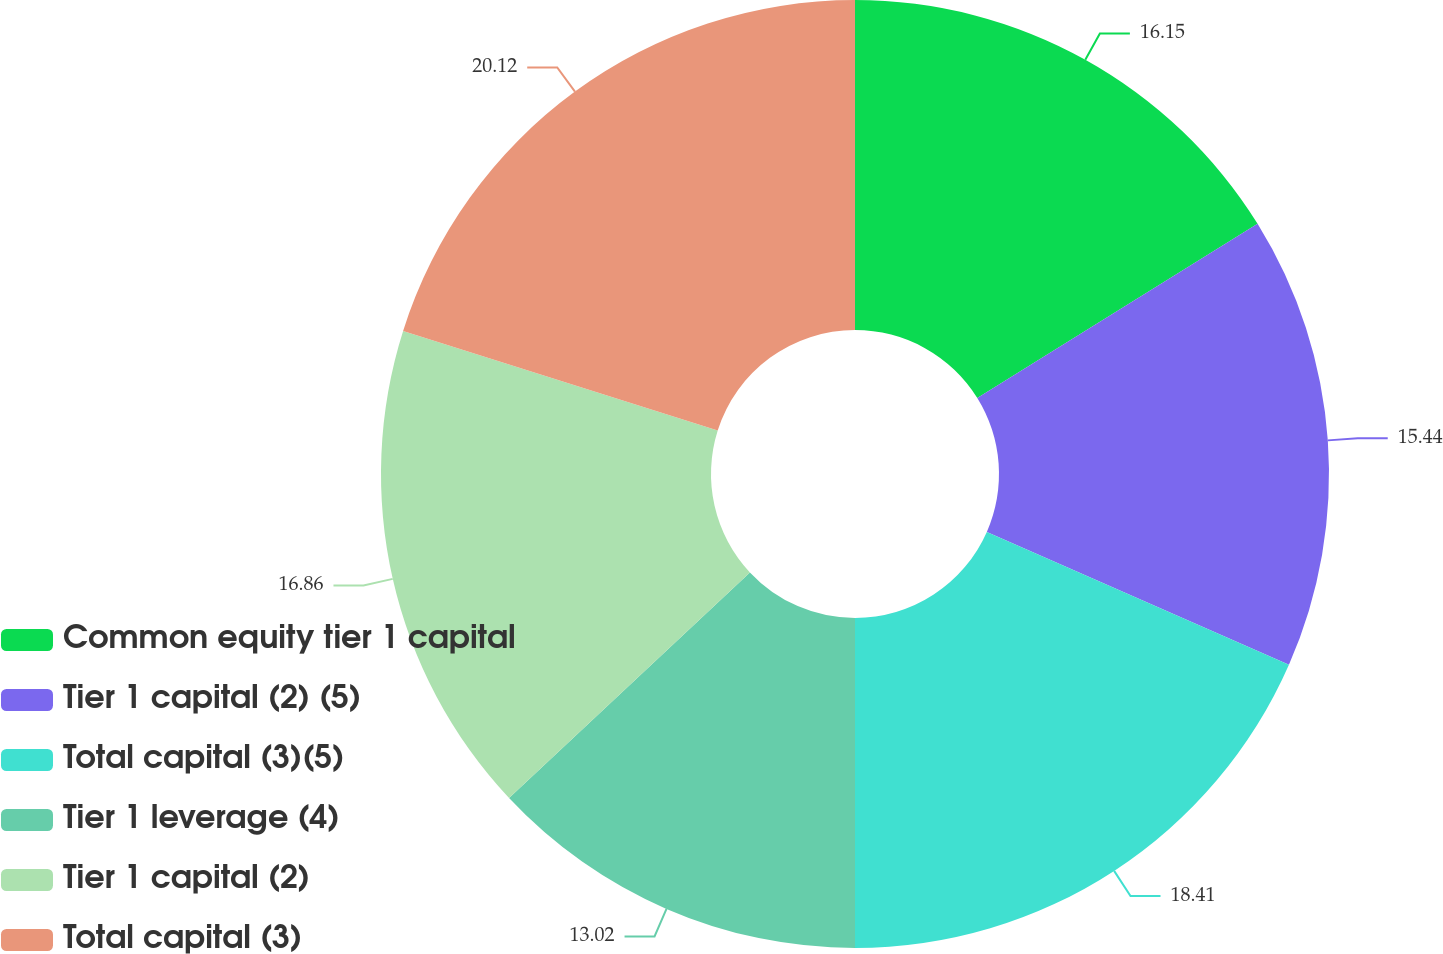Convert chart. <chart><loc_0><loc_0><loc_500><loc_500><pie_chart><fcel>Common equity tier 1 capital<fcel>Tier 1 capital (2) (5)<fcel>Total capital (3)(5)<fcel>Tier 1 leverage (4)<fcel>Tier 1 capital (2)<fcel>Total capital (3)<nl><fcel>16.15%<fcel>15.44%<fcel>18.41%<fcel>13.02%<fcel>16.86%<fcel>20.12%<nl></chart> 